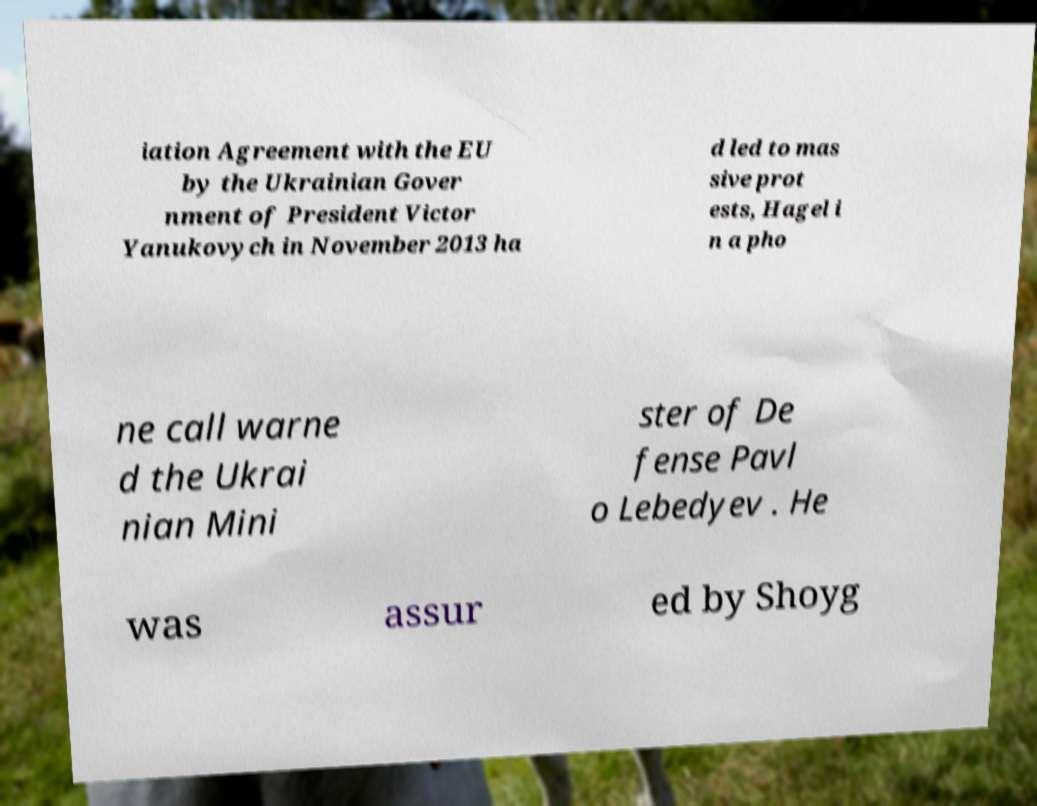There's text embedded in this image that I need extracted. Can you transcribe it verbatim? iation Agreement with the EU by the Ukrainian Gover nment of President Victor Yanukovych in November 2013 ha d led to mas sive prot ests, Hagel i n a pho ne call warne d the Ukrai nian Mini ster of De fense Pavl o Lebedyev . He was assur ed by Shoyg 